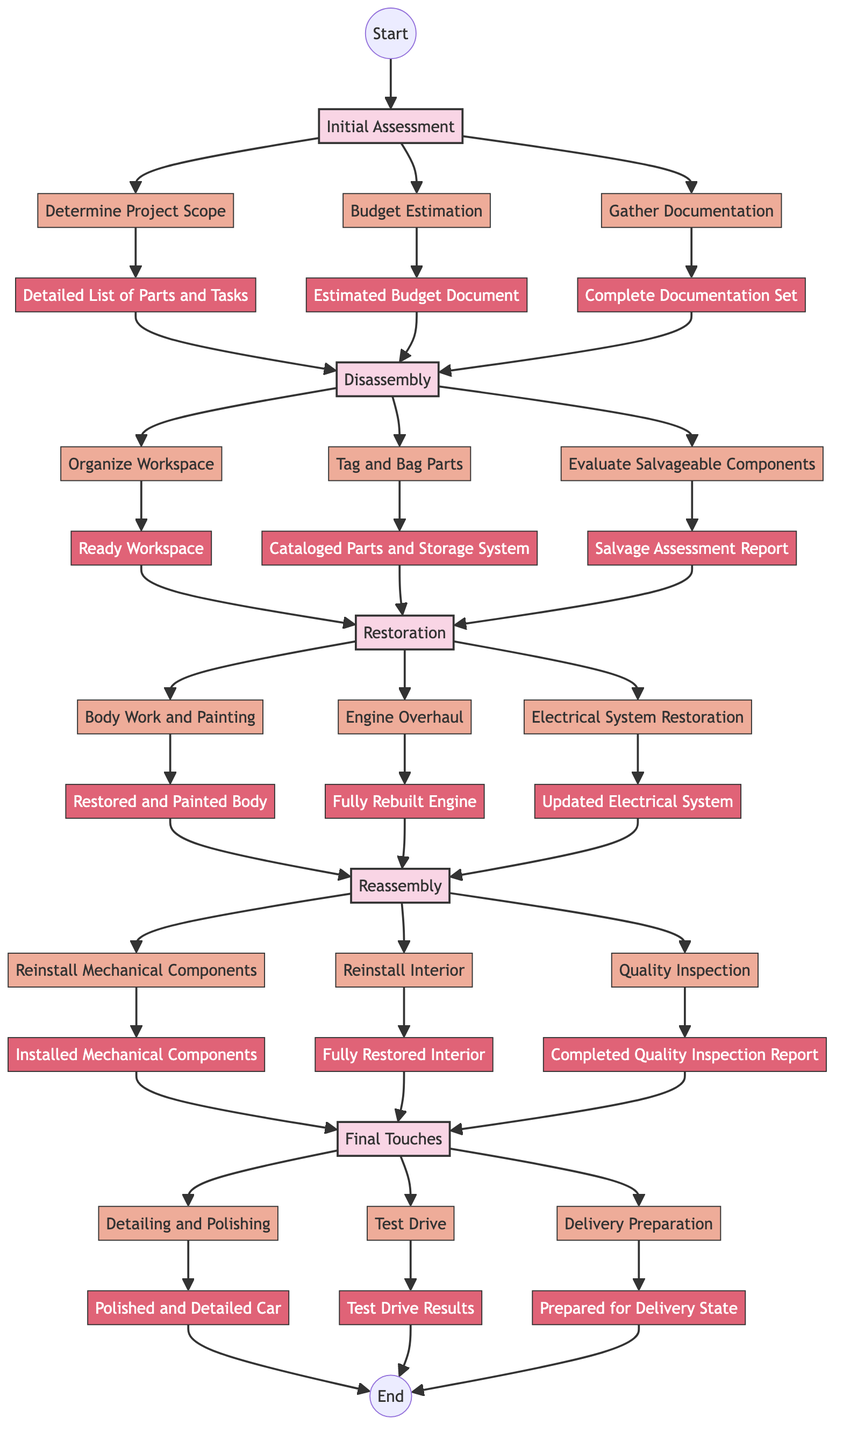What's the first phase in the restoration project? The flowchart indicates the first phase is labeled as "Initial Assessment." This is the first step in the series of phases for the vintage car restoration planning process.
Answer: Initial Assessment How many steps are in the Restoration phase? In the "Restoration" phase, there are three specific steps listed: "Body Work and Painting," "Engine Overhaul," and "Electrical System Restoration." Counting these gives a total of three steps in that phase.
Answer: 3 What is the output of the step "Test Drive"? The output for the step labeled "Test Drive" is "Test Drive Results." This output refers to the documentation or findings from performing the test drive on the restored vehicle.
Answer: Test Drive Results Which step follows "Budget Estimation"? After "Budget Estimation," the next step in the flowchart is "Gather Documentation." This step outlines the importance of collecting necessary records and manuals for the restoration process.
Answer: Gather Documentation What are the outputs of the "Reassembly" phase steps? The outputs of the steps in the "Reassembly" phase are: "Installed Mechanical Components," "Fully Restored Interior," and "Completed Quality Inspection Report." These outputs reflect the results of the actions taken during this phase.
Answer: Installed Mechanical Components, Fully Restored Interior, Completed Quality Inspection Report What is the last step in the process before reaching the end? The last step before reaching the "End" node in the flowchart is "Delivery Preparation." This step involves getting the documentation and vehicle ready for delivery to the client, marking the final preparation stage of the project.
Answer: Delivery Preparation How does the step "Evaluate Salvageable Components" relate to "Tag and Bag Parts"? "Evaluate Salvageable Components" follows "Tag and Bag Parts" in the flowchart. This indicates that after organizing and labeling the parts from disassembly, the next logical step involves assessing which parts can be restored or need replacement, showing a sequential flow from organizing to evaluating.
Answer: Evaluate Salvageable Components What is the output of the first step? The output of the first step "Determine Project Scope" is "Detailed List of Parts and Tasks." This output represents the essential documentation created from the initial assessment of the vehicle's needs.
Answer: Detailed List of Parts and Tasks How many phases are there in total in the restoration process? The flowchart reveals there are five distinct phases in the vintage car restoration planning, indicating the complete structure and process. Each phase sequentially contributes to the overall project.
Answer: 5 